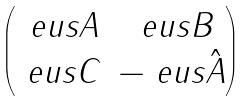Convert formula to latex. <formula><loc_0><loc_0><loc_500><loc_500>\begin{pmatrix} \ e u s A & \ e u s B \\ \ e u s C & - \ e u s { \hat { A } } \end{pmatrix}</formula> 